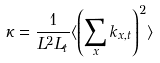<formula> <loc_0><loc_0><loc_500><loc_500>\kappa = \frac { 1 } { L ^ { 2 } L _ { t } } \langle \left ( \sum _ { x } k _ { x , t } \right ) ^ { 2 } \rangle</formula> 